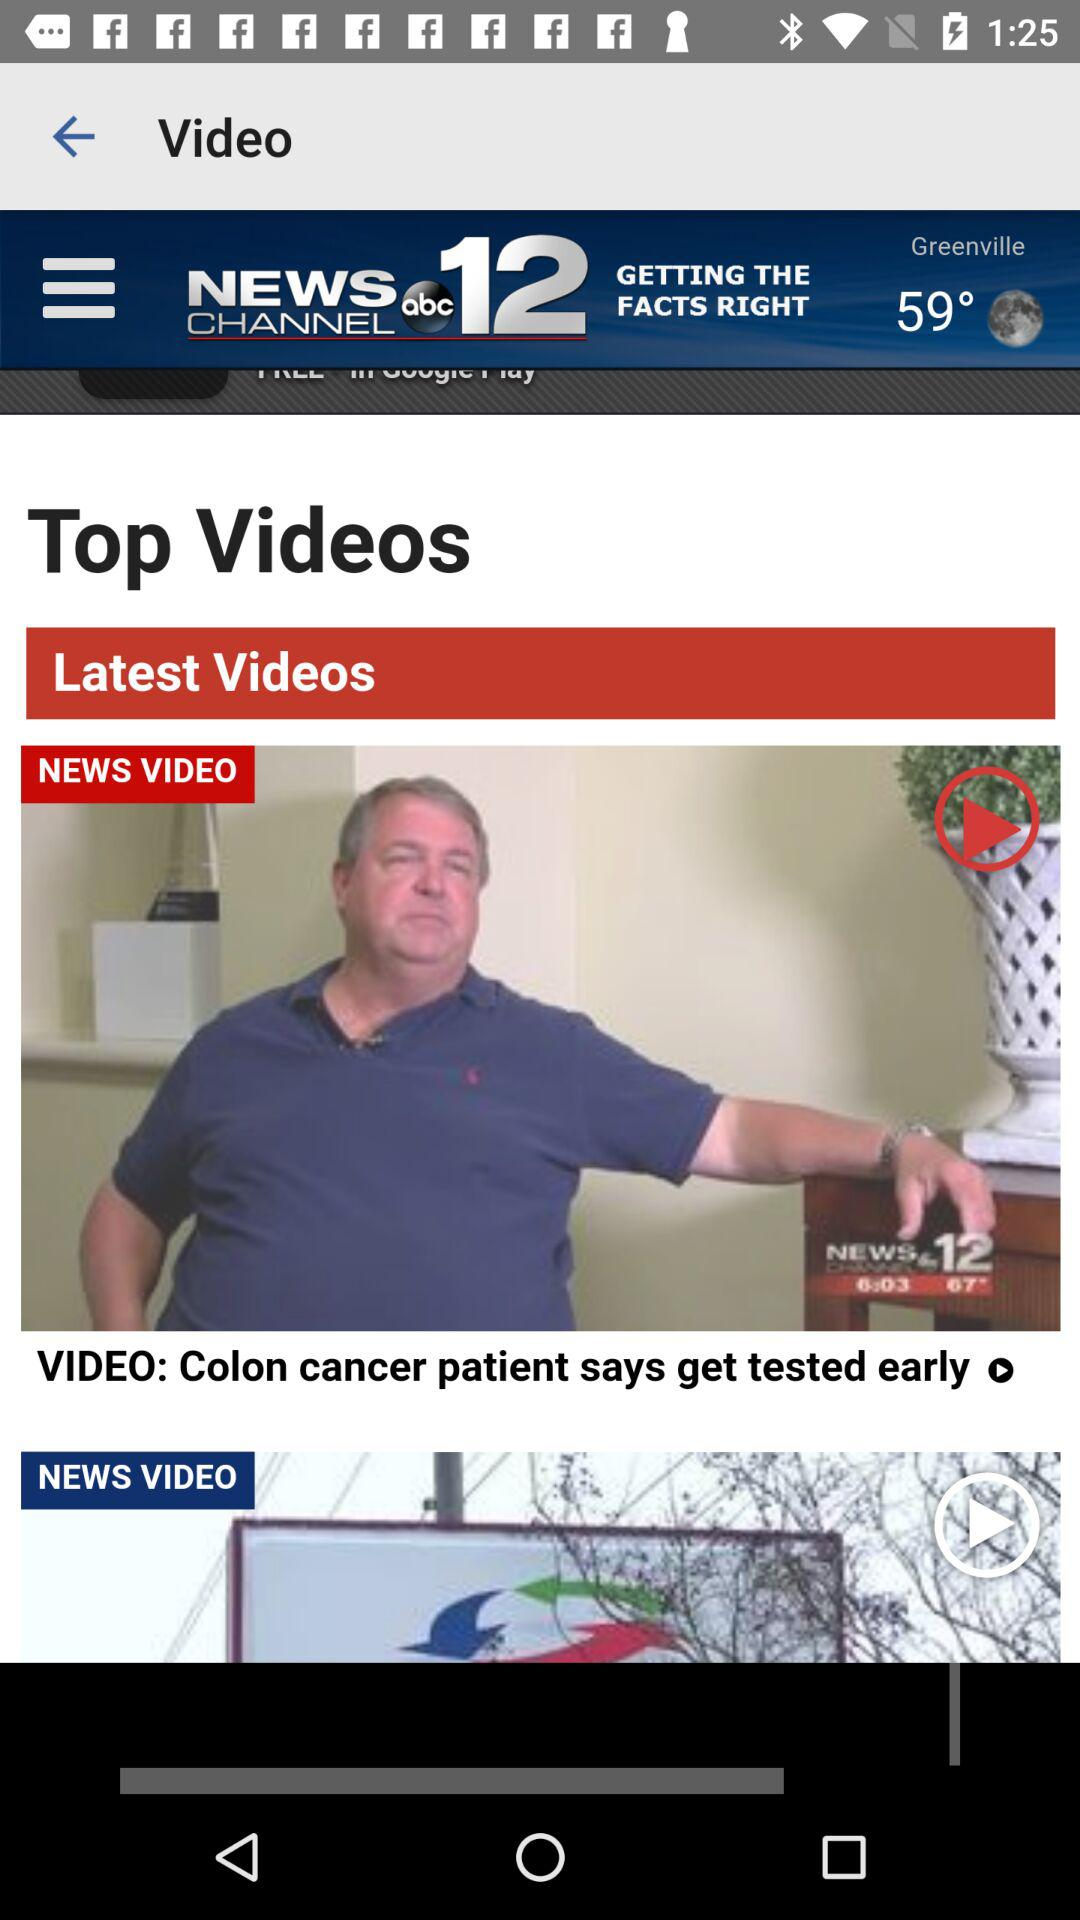What is the name of the application? The application name is "abc 12". 